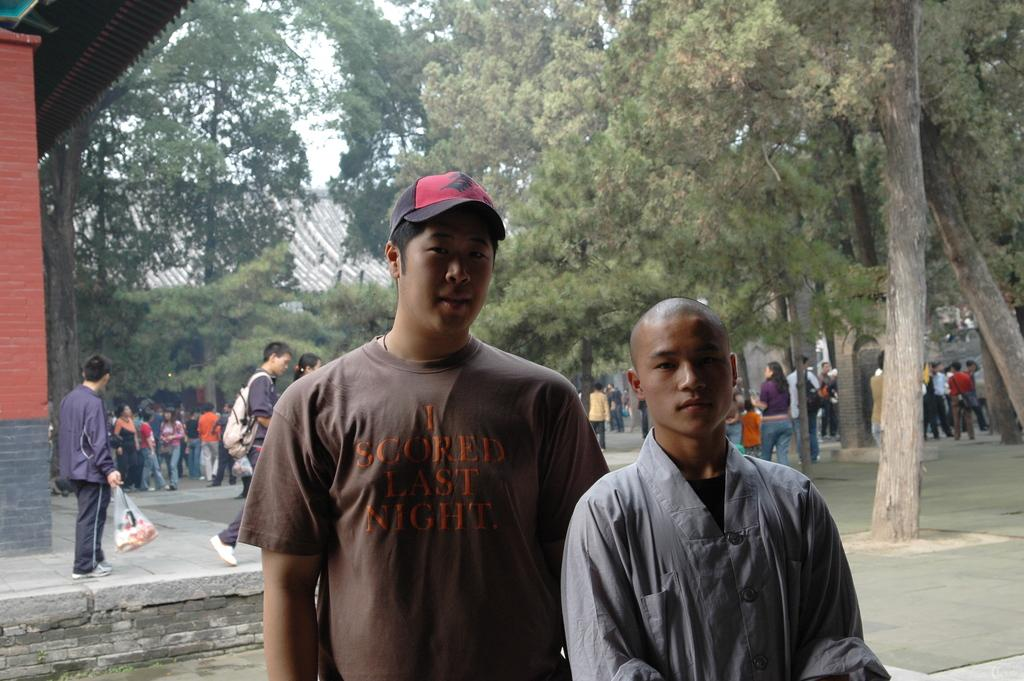How many men are in the foreground of the image? There are two men in the foreground of the image. What type of natural elements can be seen in the image? There are trees in the image. What type of man-made structures are present in the image? There are buildings in the image. What type of surface are the men standing on? There is a pavement in the image. Can you describe the people in the image? There are people in the image. What is visible at the top of the image? The sky is visible at the top of the image. What type of crime is being committed in the image? There is no indication of any crime being committed in the image. What type of plant is growing in the middle of the pavement? There is no plant growing in the middle of the pavement in the image. 